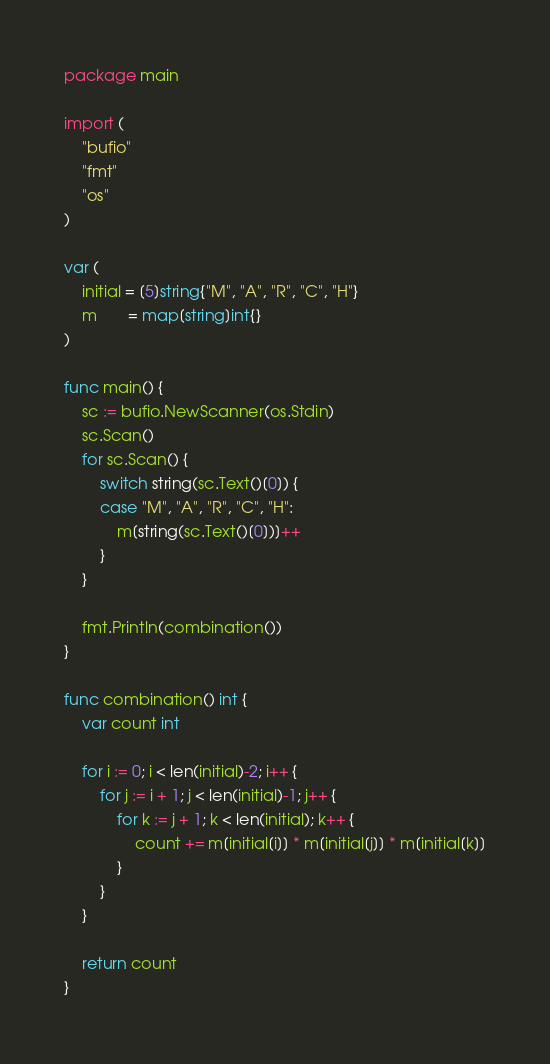Convert code to text. <code><loc_0><loc_0><loc_500><loc_500><_Go_>package main

import (
	"bufio"
	"fmt"
	"os"
)

var (
	initial = [5]string{"M", "A", "R", "C", "H"}
	m       = map[string]int{}
)

func main() {
	sc := bufio.NewScanner(os.Stdin)
	sc.Scan()
	for sc.Scan() {
		switch string(sc.Text()[0]) {
		case "M", "A", "R", "C", "H":
			m[string(sc.Text()[0])]++
		}
	}

	fmt.Println(combination())
}

func combination() int {
	var count int

	for i := 0; i < len(initial)-2; i++ {
		for j := i + 1; j < len(initial)-1; j++ {
			for k := j + 1; k < len(initial); k++ {
				count += m[initial[i]] * m[initial[j]] * m[initial[k]]
			}
		}
	}

	return count
}
</code> 